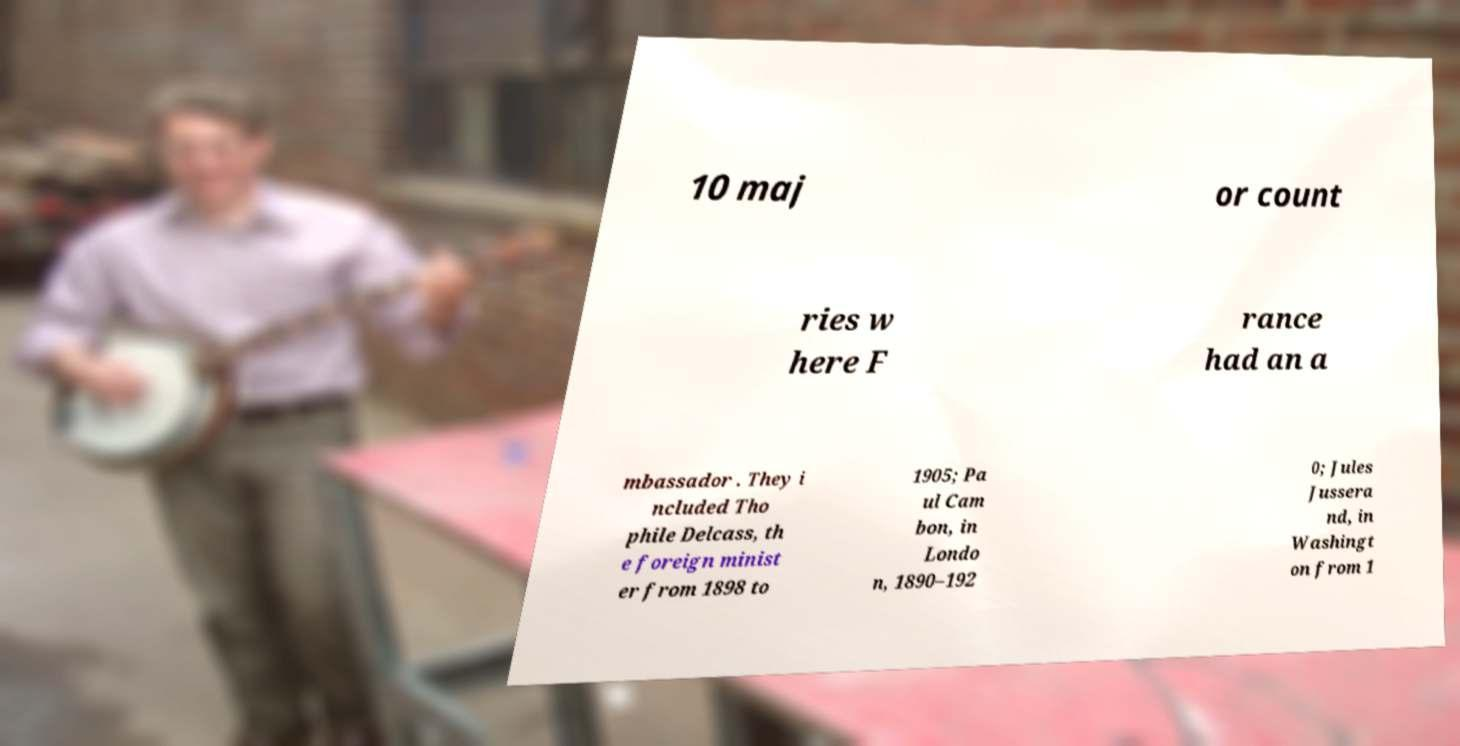Could you assist in decoding the text presented in this image and type it out clearly? 10 maj or count ries w here F rance had an a mbassador . They i ncluded Tho phile Delcass, th e foreign minist er from 1898 to 1905; Pa ul Cam bon, in Londo n, 1890–192 0; Jules Jussera nd, in Washingt on from 1 